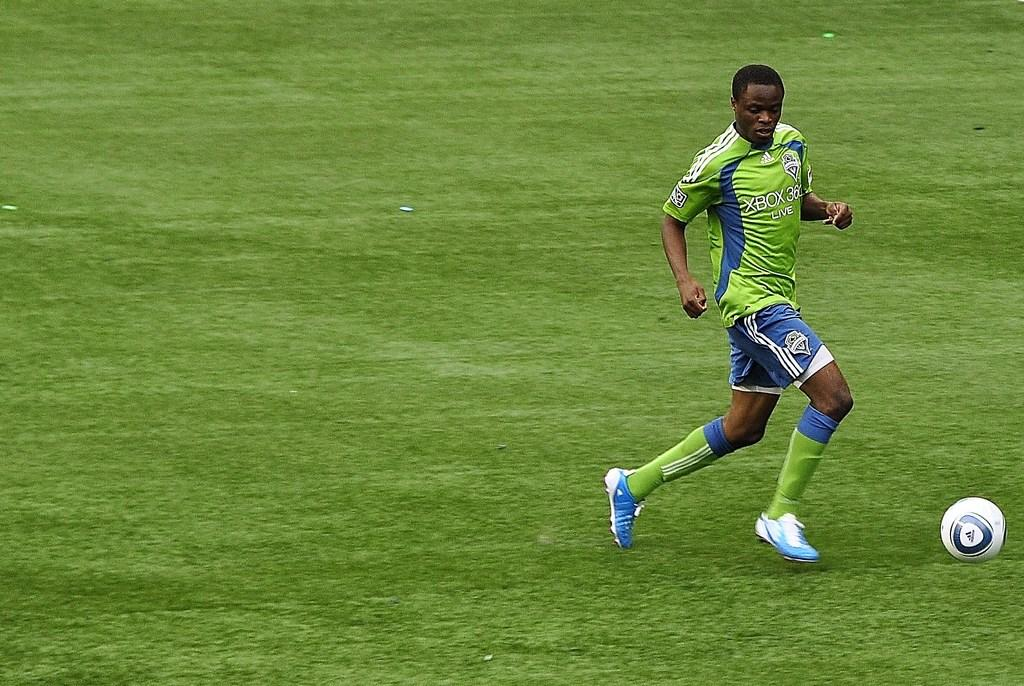Provide a one-sentence caption for the provided image. A soccer player runs with the ball wearing an xbox jersey. 